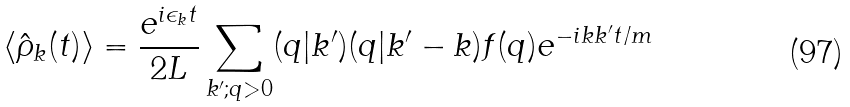Convert formula to latex. <formula><loc_0><loc_0><loc_500><loc_500>\langle { \hat { \rho } } _ { k } ( t ) \rangle = \frac { e ^ { i \epsilon _ { k } t } } { 2 L } \sum _ { k ^ { \prime } ; q > 0 } ( q | k ^ { \prime } ) ( q | k ^ { \prime } - k ) f ( q ) e ^ { - i k k ^ { \prime } t / m }</formula> 